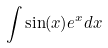Convert formula to latex. <formula><loc_0><loc_0><loc_500><loc_500>\int \sin ( x ) e ^ { x } d x</formula> 